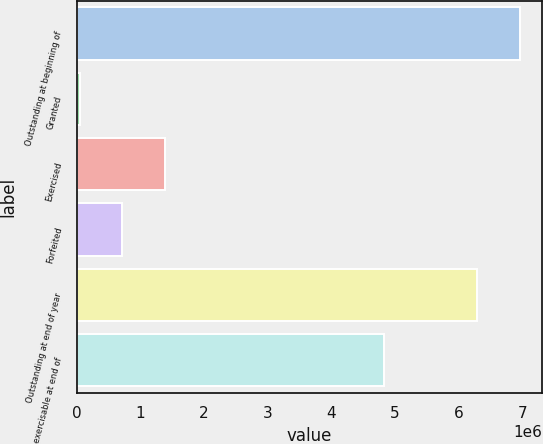Convert chart. <chart><loc_0><loc_0><loc_500><loc_500><bar_chart><fcel>Outstanding at beginning of<fcel>Granted<fcel>Exercised<fcel>Forfeited<fcel>Outstanding at end of year<fcel>Options exercisable at end of<nl><fcel>6.9697e+06<fcel>42206<fcel>1.39213e+06<fcel>717168<fcel>6.29474e+06<fcel>4.83512e+06<nl></chart> 